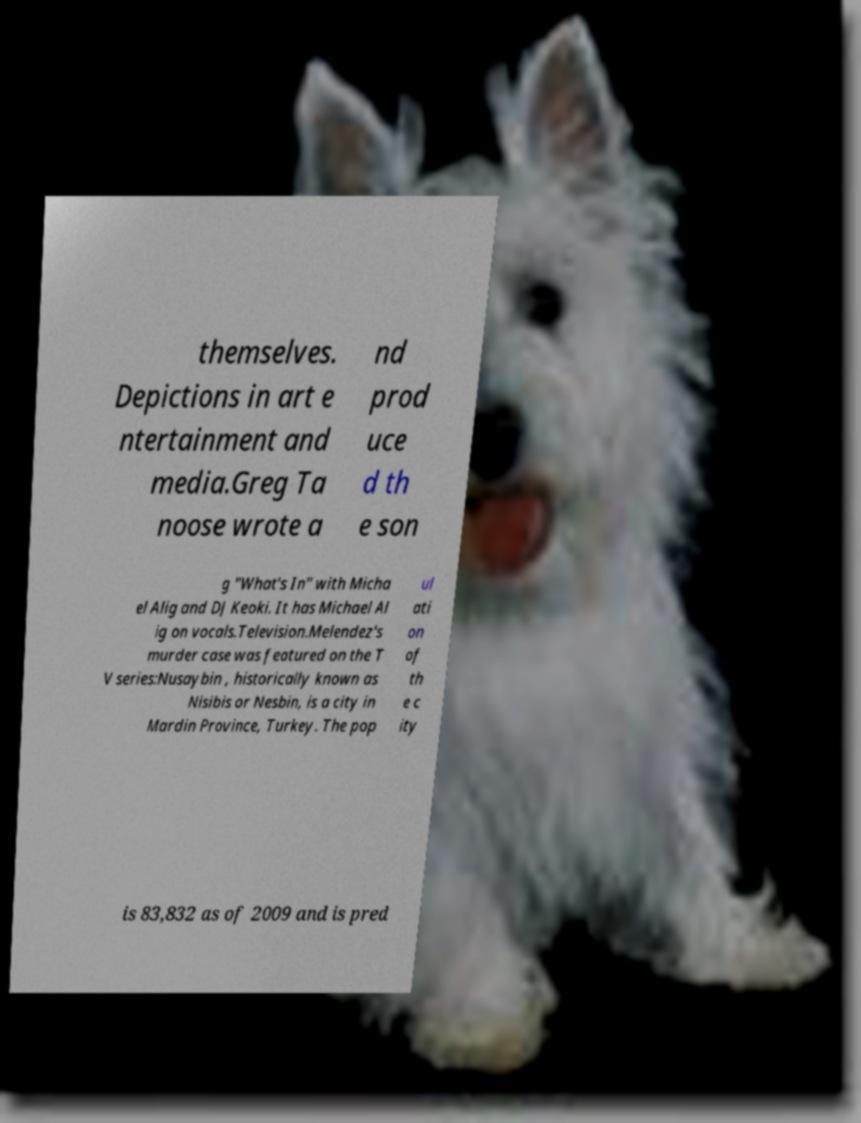For documentation purposes, I need the text within this image transcribed. Could you provide that? themselves. Depictions in art e ntertainment and media.Greg Ta noose wrote a nd prod uce d th e son g "What's In" with Micha el Alig and DJ Keoki. It has Michael Al ig on vocals.Television.Melendez's murder case was featured on the T V series:Nusaybin , historically known as Nisibis or Nesbin, is a city in Mardin Province, Turkey. The pop ul ati on of th e c ity is 83,832 as of 2009 and is pred 